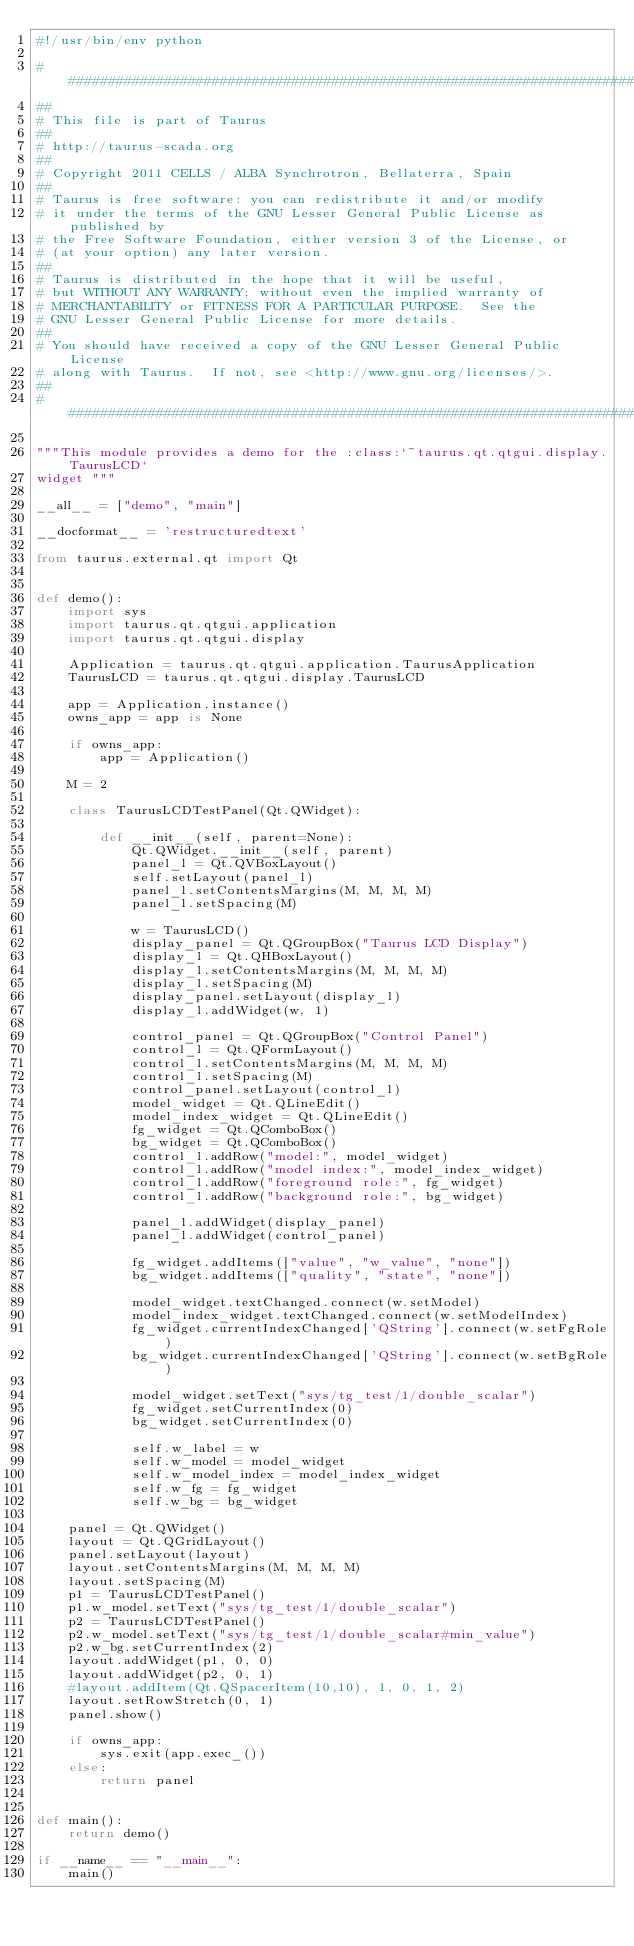<code> <loc_0><loc_0><loc_500><loc_500><_Python_>#!/usr/bin/env python

#############################################################################
##
# This file is part of Taurus
##
# http://taurus-scada.org
##
# Copyright 2011 CELLS / ALBA Synchrotron, Bellaterra, Spain
##
# Taurus is free software: you can redistribute it and/or modify
# it under the terms of the GNU Lesser General Public License as published by
# the Free Software Foundation, either version 3 of the License, or
# (at your option) any later version.
##
# Taurus is distributed in the hope that it will be useful,
# but WITHOUT ANY WARRANTY; without even the implied warranty of
# MERCHANTABILITY or FITNESS FOR A PARTICULAR PURPOSE.  See the
# GNU Lesser General Public License for more details.
##
# You should have received a copy of the GNU Lesser General Public License
# along with Taurus.  If not, see <http://www.gnu.org/licenses/>.
##
#############################################################################

"""This module provides a demo for the :class:`~taurus.qt.qtgui.display.TaurusLCD`
widget """

__all__ = ["demo", "main"]

__docformat__ = 'restructuredtext'

from taurus.external.qt import Qt


def demo():
    import sys
    import taurus.qt.qtgui.application
    import taurus.qt.qtgui.display

    Application = taurus.qt.qtgui.application.TaurusApplication
    TaurusLCD = taurus.qt.qtgui.display.TaurusLCD

    app = Application.instance()
    owns_app = app is None

    if owns_app:
        app = Application()

    M = 2

    class TaurusLCDTestPanel(Qt.QWidget):

        def __init__(self, parent=None):
            Qt.QWidget.__init__(self, parent)
            panel_l = Qt.QVBoxLayout()
            self.setLayout(panel_l)
            panel_l.setContentsMargins(M, M, M, M)
            panel_l.setSpacing(M)

            w = TaurusLCD()
            display_panel = Qt.QGroupBox("Taurus LCD Display")
            display_l = Qt.QHBoxLayout()
            display_l.setContentsMargins(M, M, M, M)
            display_l.setSpacing(M)
            display_panel.setLayout(display_l)
            display_l.addWidget(w, 1)

            control_panel = Qt.QGroupBox("Control Panel")
            control_l = Qt.QFormLayout()
            control_l.setContentsMargins(M, M, M, M)
            control_l.setSpacing(M)
            control_panel.setLayout(control_l)
            model_widget = Qt.QLineEdit()
            model_index_widget = Qt.QLineEdit()
            fg_widget = Qt.QComboBox()
            bg_widget = Qt.QComboBox()
            control_l.addRow("model:", model_widget)
            control_l.addRow("model index:", model_index_widget)
            control_l.addRow("foreground role:", fg_widget)
            control_l.addRow("background role:", bg_widget)

            panel_l.addWidget(display_panel)
            panel_l.addWidget(control_panel)

            fg_widget.addItems(["value", "w_value", "none"])
            bg_widget.addItems(["quality", "state", "none"])

            model_widget.textChanged.connect(w.setModel)
            model_index_widget.textChanged.connect(w.setModelIndex)
            fg_widget.currentIndexChanged['QString'].connect(w.setFgRole)
            bg_widget.currentIndexChanged['QString'].connect(w.setBgRole)

            model_widget.setText("sys/tg_test/1/double_scalar")
            fg_widget.setCurrentIndex(0)
            bg_widget.setCurrentIndex(0)

            self.w_label = w
            self.w_model = model_widget
            self.w_model_index = model_index_widget
            self.w_fg = fg_widget
            self.w_bg = bg_widget

    panel = Qt.QWidget()
    layout = Qt.QGridLayout()
    panel.setLayout(layout)
    layout.setContentsMargins(M, M, M, M)
    layout.setSpacing(M)
    p1 = TaurusLCDTestPanel()
    p1.w_model.setText("sys/tg_test/1/double_scalar")
    p2 = TaurusLCDTestPanel()
    p2.w_model.setText("sys/tg_test/1/double_scalar#min_value")
    p2.w_bg.setCurrentIndex(2)
    layout.addWidget(p1, 0, 0)
    layout.addWidget(p2, 0, 1)
    #layout.addItem(Qt.QSpacerItem(10,10), 1, 0, 1, 2)
    layout.setRowStretch(0, 1)
    panel.show()

    if owns_app:
        sys.exit(app.exec_())
    else:
        return panel


def main():
    return demo()

if __name__ == "__main__":
    main()
</code> 